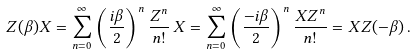<formula> <loc_0><loc_0><loc_500><loc_500>Z ( \beta ) X = \sum _ { n = 0 } ^ { \infty } \left ( \frac { i \beta } { 2 } \right ) ^ { n } \frac { Z ^ { n } } { n ! } \, X = \sum _ { n = 0 } ^ { \infty } \left ( \frac { - i \beta } { 2 } \right ) ^ { n } \frac { X Z ^ { n } } { n ! } = X Z ( - \beta ) \, .</formula> 